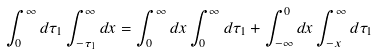<formula> <loc_0><loc_0><loc_500><loc_500>\int _ { 0 } ^ { \infty } d \tau _ { 1 } \int _ { - \tau _ { 1 } } ^ { \infty } d x = \int _ { 0 } ^ { \infty } d x \int _ { 0 } ^ { \infty } d \tau _ { 1 } + \int _ { - \infty } ^ { 0 } d x \int _ { - x } ^ { \infty } d \tau _ { 1 }</formula> 